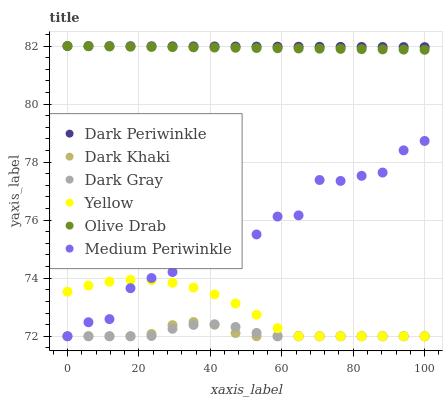Does Dark Khaki have the minimum area under the curve?
Answer yes or no. Yes. Does Dark Periwinkle have the maximum area under the curve?
Answer yes or no. Yes. Does Medium Periwinkle have the minimum area under the curve?
Answer yes or no. No. Does Medium Periwinkle have the maximum area under the curve?
Answer yes or no. No. Is Olive Drab the smoothest?
Answer yes or no. Yes. Is Medium Periwinkle the roughest?
Answer yes or no. Yes. Is Yellow the smoothest?
Answer yes or no. No. Is Yellow the roughest?
Answer yes or no. No. Does Dark Gray have the lowest value?
Answer yes or no. Yes. Does Dark Periwinkle have the lowest value?
Answer yes or no. No. Does Olive Drab have the highest value?
Answer yes or no. Yes. Does Medium Periwinkle have the highest value?
Answer yes or no. No. Is Dark Khaki less than Dark Periwinkle?
Answer yes or no. Yes. Is Olive Drab greater than Medium Periwinkle?
Answer yes or no. Yes. Does Medium Periwinkle intersect Dark Khaki?
Answer yes or no. Yes. Is Medium Periwinkle less than Dark Khaki?
Answer yes or no. No. Is Medium Periwinkle greater than Dark Khaki?
Answer yes or no. No. Does Dark Khaki intersect Dark Periwinkle?
Answer yes or no. No. 